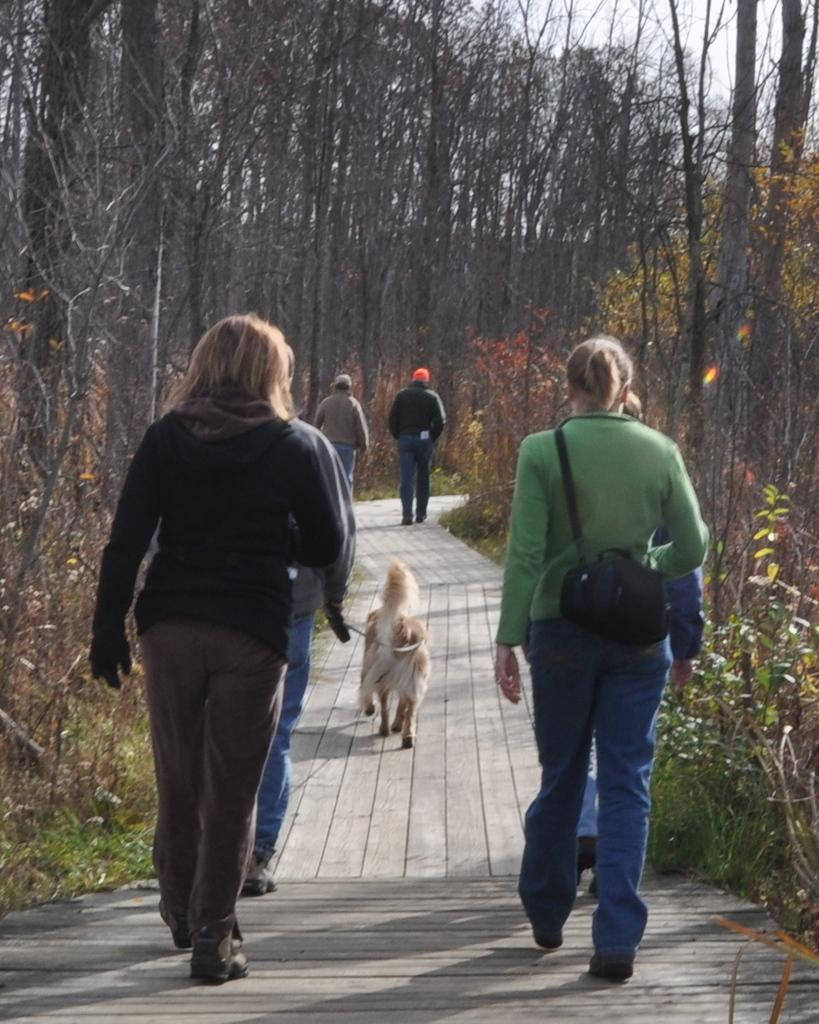What can be seen in the image that people walk on? There is a path in the image that people walk on. Can you describe the people on the path? There are people on the path in the image. What type of animal is present in the image? There is a dog in the image, which is white and cream in color. What other natural elements can be seen in the image? There are plants and trees in the image. What is visible above the path and trees? The sky is visible in the image. Can you read the writing on the dog's collar in the image? There is no writing on the dog's collar in the image, as it is not mentioned in the provided facts. 